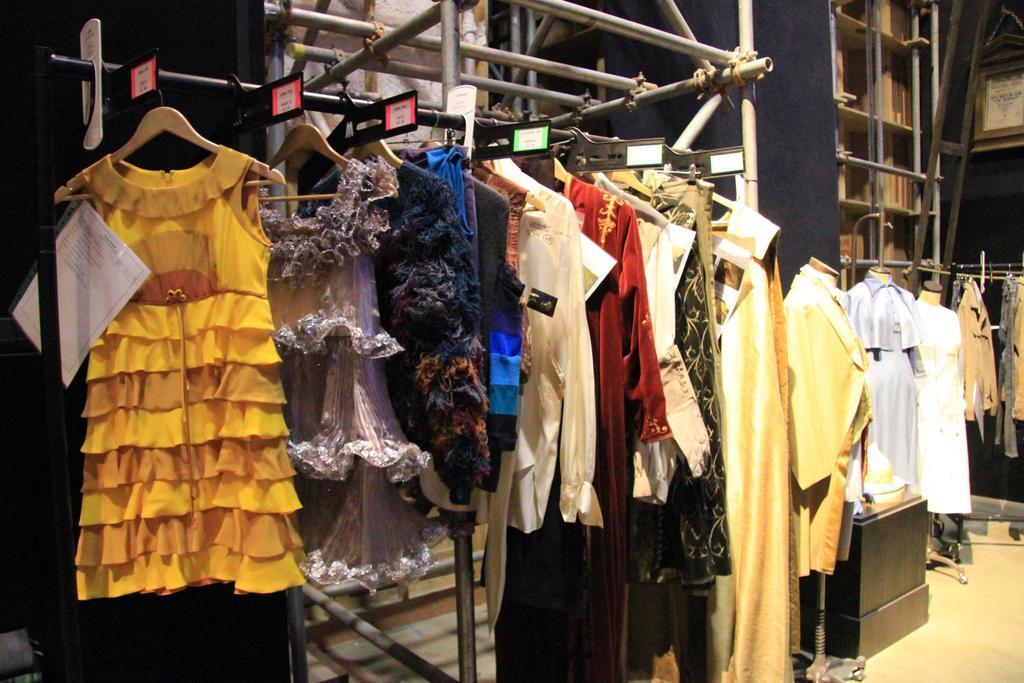Please provide a concise description of this image. This image consists of dresses in the middle. This looks like a store. There are hangers and mannequins. 